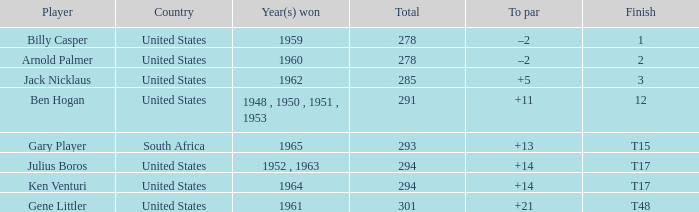What is the year(s) achieved when the total is below 285? 1959, 1960. 